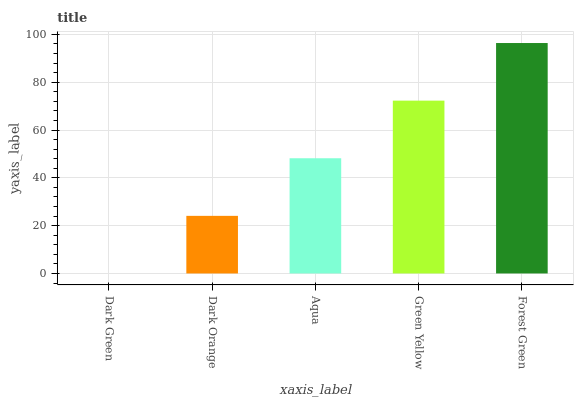Is Dark Green the minimum?
Answer yes or no. Yes. Is Forest Green the maximum?
Answer yes or no. Yes. Is Dark Orange the minimum?
Answer yes or no. No. Is Dark Orange the maximum?
Answer yes or no. No. Is Dark Orange greater than Dark Green?
Answer yes or no. Yes. Is Dark Green less than Dark Orange?
Answer yes or no. Yes. Is Dark Green greater than Dark Orange?
Answer yes or no. No. Is Dark Orange less than Dark Green?
Answer yes or no. No. Is Aqua the high median?
Answer yes or no. Yes. Is Aqua the low median?
Answer yes or no. Yes. Is Dark Orange the high median?
Answer yes or no. No. Is Green Yellow the low median?
Answer yes or no. No. 